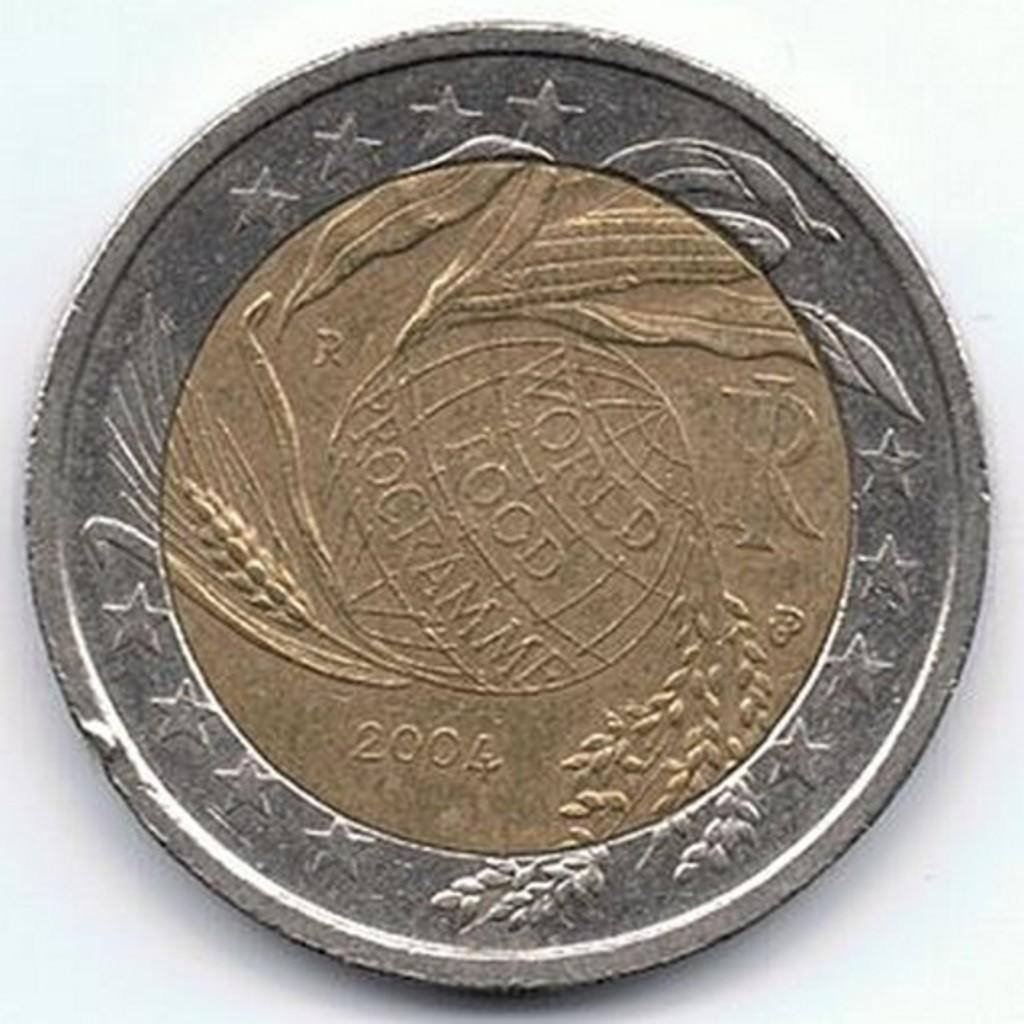<image>
Write a terse but informative summary of the picture. A gold and silver coin from 2004 sits on a white table 